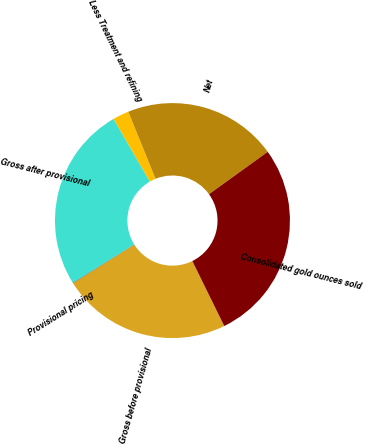Convert chart. <chart><loc_0><loc_0><loc_500><loc_500><pie_chart><fcel>Gross before provisional<fcel>Provisional pricing<fcel>Gross after provisional<fcel>Less Treatment and refining<fcel>Net<fcel>Consolidated gold ounces sold<nl><fcel>23.35%<fcel>0.05%<fcel>25.52%<fcel>2.21%<fcel>21.19%<fcel>27.68%<nl></chart> 